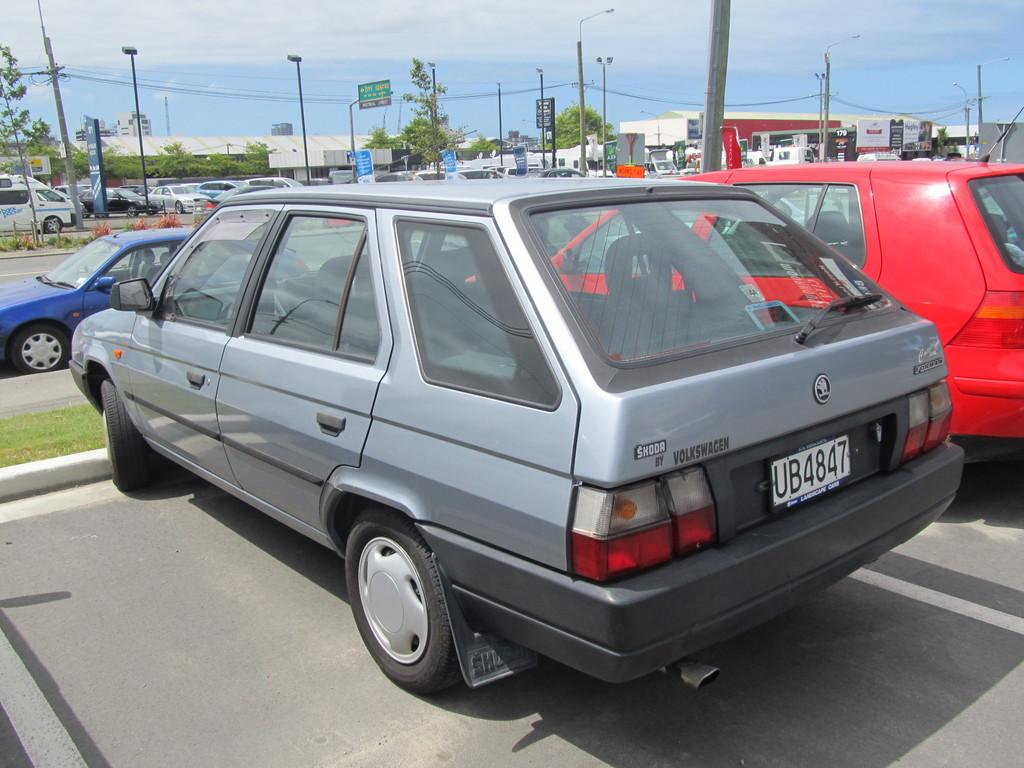What can be seen on the road in the image? There are cars parked on the road in the image. What type of structures are visible in the image? There are buildings visible in the image. What type of vegetation is present in the image? Trees are present in the image. What type of lighting is present in the image? Street lights are in the image. What type of signage is visible in the image? Sign boards are visible in the image. What type of surface is present in the image? Grass is present on the surface in the image. What can be seen in the background of the image? The sky is visible in the background of the image. Can you tell me how many elbows are visible in the image? There are no elbows visible in the image. What type of wave can be seen crashing on the shore in the image? There is no shore or wave present in the image. 